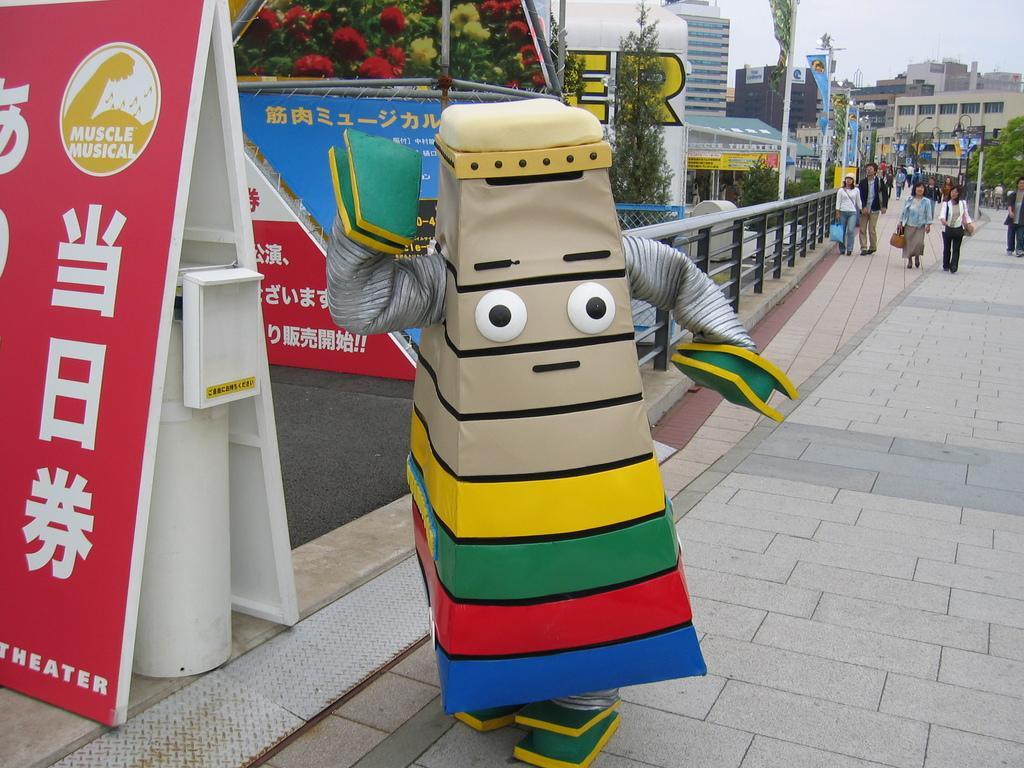Could you give a brief overview of what you see in this image? In this image in the center there are group of persons walking. In the front there is a person wearing a costume and standing and there are banners with some text written on it. In the background there are flags, buildings, trees, and there is a railing. 